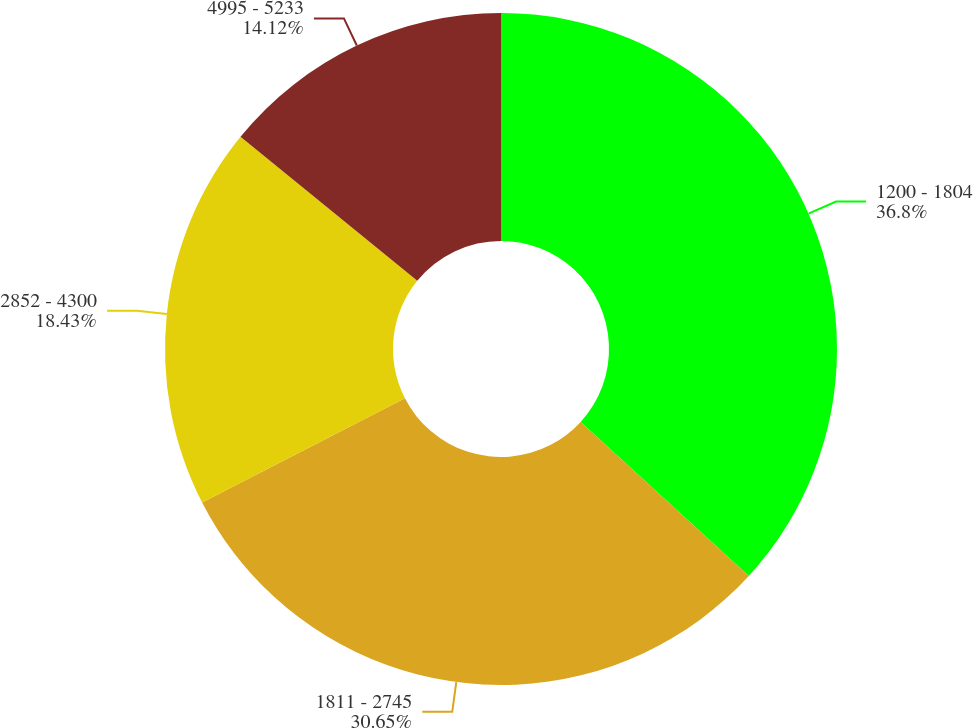Convert chart to OTSL. <chart><loc_0><loc_0><loc_500><loc_500><pie_chart><fcel>1200 - 1804<fcel>1811 - 2745<fcel>2852 - 4300<fcel>4995 - 5233<nl><fcel>36.8%<fcel>30.65%<fcel>18.43%<fcel>14.12%<nl></chart> 